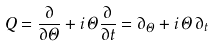<formula> <loc_0><loc_0><loc_500><loc_500>Q = \frac { \partial } { \partial \Theta } + i \, \Theta \frac { \partial } { \partial t } = \partial _ { \Theta } + i \, \Theta \, \partial _ { t }</formula> 